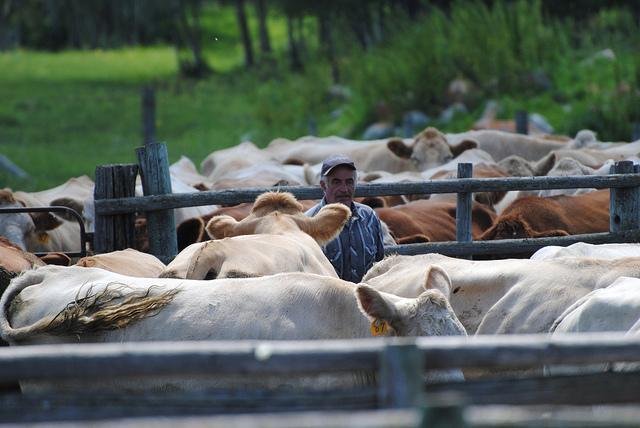How many cows are there?
Give a very brief answer. 11. How many cars have zebra stripes?
Give a very brief answer. 0. 